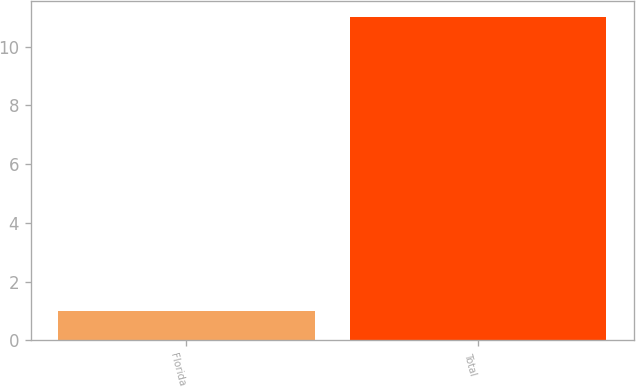Convert chart to OTSL. <chart><loc_0><loc_0><loc_500><loc_500><bar_chart><fcel>Florida<fcel>Total<nl><fcel>1<fcel>11<nl></chart> 